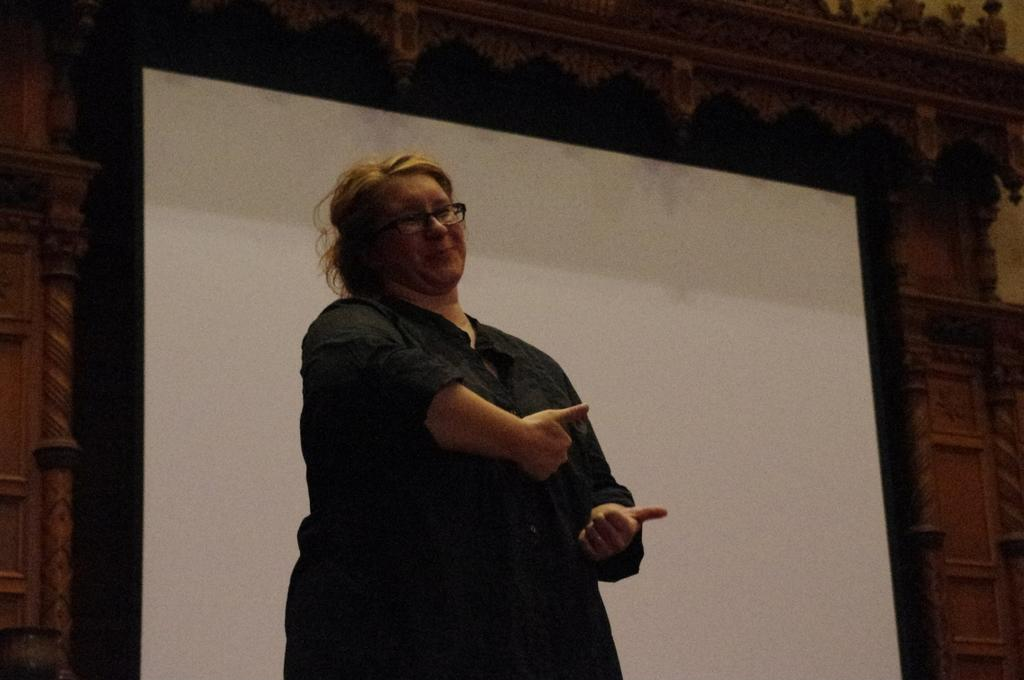Who is present in the image? There is a woman in the image. What is the woman wearing? The woman is wearing a black dress. What is the woman doing in the image? The woman is standing. What can be seen behind the woman? There is a projector behind the woman. What is visible in the background of the image? There is a designed wall in the background of the image. How many bags does the woman have with her in the image? There is no mention of bags in the image, so we cannot determine how many the woman has. What type of beast can be seen interacting with the woman in the image? There is no beast present in the image; it only features a woman, a projector, and a designed wall. 